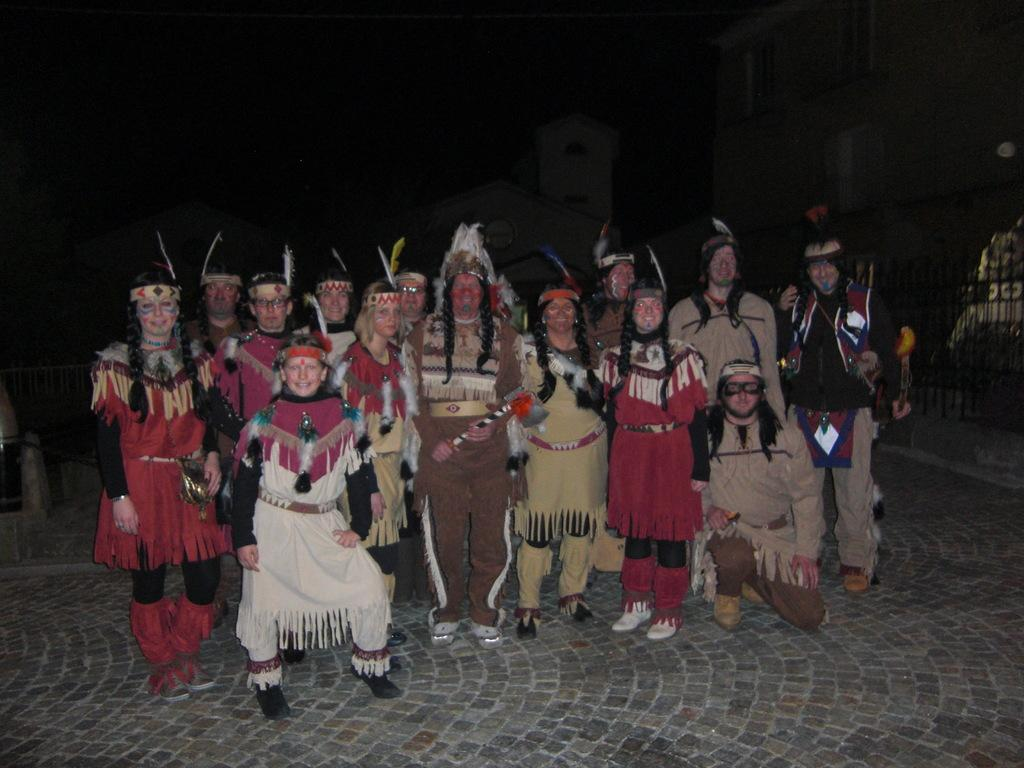How many people are in the image? There is a group of persons in the image. What are the persons doing in the image? The persons are standing on the ground. What type of clothing are the persons wearing? The persons are wearing ancient dress. What is the lighting condition in the top part of the image? The top part of the image appears to be dark. What type of cable can be seen connecting the persons in the image? There is no cable connecting the persons in the image; they are simply standing on the ground. What kind of musical instruments is the band playing in the image? There is no band or musical instruments present in the image. 